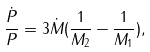<formula> <loc_0><loc_0><loc_500><loc_500>\frac { \dot { P } } { P } = 3 \dot { M } ( \frac { 1 } { M _ { 2 } } - \frac { 1 } { M _ { 1 } } ) ,</formula> 